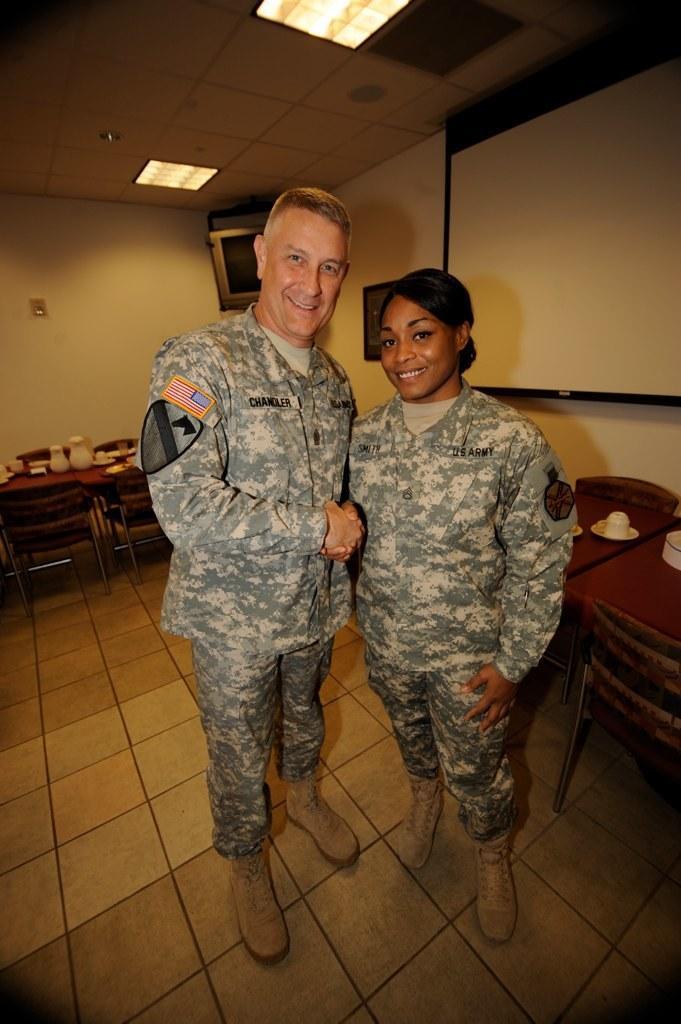Could you give a brief overview of what you see in this image? In this image, there are two persons standing and wearing clothes. There are some tables and chairs behind these persons. There is a screen behind this person. There is a TV behind this person. This table contains cups and saucers. There are two lights at the top. There is a wall behind these persons. 